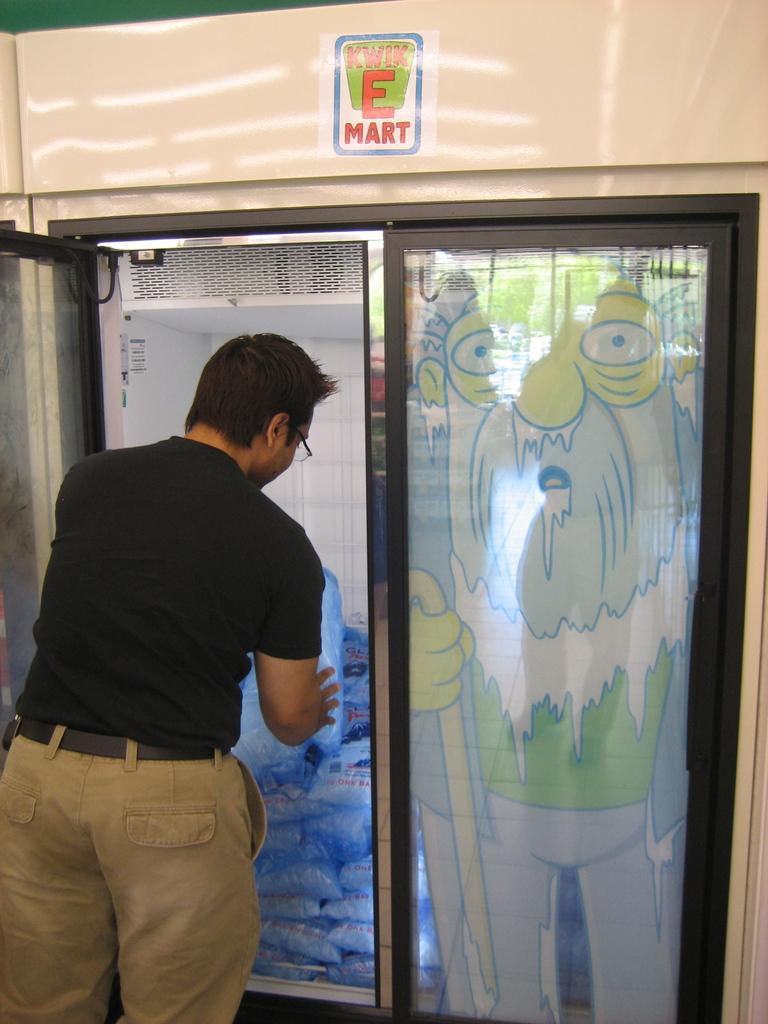<image>
Write a terse but informative summary of the picture. the words Kwik E Mart is on the sign above the 